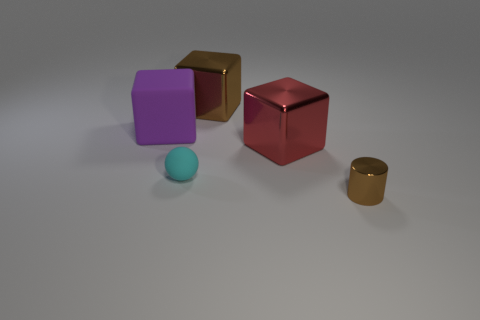There is a large brown block; are there any shiny cylinders left of it?
Keep it short and to the point. No. There is a brown thing behind the tiny metal cylinder; are there any tiny cyan matte spheres that are behind it?
Provide a succinct answer. No. Are there fewer red metal blocks behind the brown metallic block than small metal things that are left of the small cyan ball?
Provide a short and direct response. No. Is there anything else that is the same size as the cyan matte sphere?
Give a very brief answer. Yes. The tiny matte object has what shape?
Offer a very short reply. Sphere. What material is the brown object that is behind the brown metal cylinder?
Provide a succinct answer. Metal. There is a metallic cube that is on the right side of the metal object that is behind the rubber object behind the small cyan object; what is its size?
Your answer should be compact. Large. Is the small thing that is in front of the tiny sphere made of the same material as the big object that is left of the large brown shiny object?
Offer a very short reply. No. What number of other objects are the same color as the small metallic thing?
Your answer should be compact. 1. What number of objects are brown things behind the brown metallic cylinder or shiny blocks behind the red block?
Keep it short and to the point. 1. 